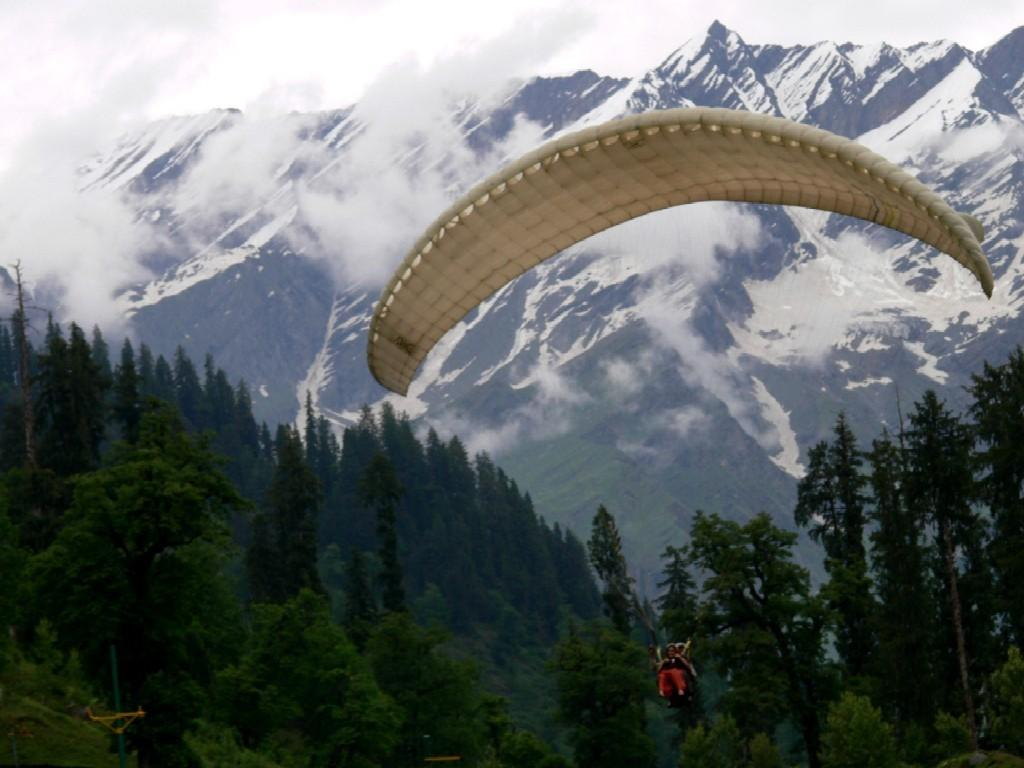What are the two persons in the image doing? The two persons in the image are parachuting. What can be seen in the background of the image? There is a forest and ice mountains visible in the background of the image. What type of vegetable is being used as a parachute in the image? There are no vegetables present in the image, and the parachutes are not made of vegetables. 